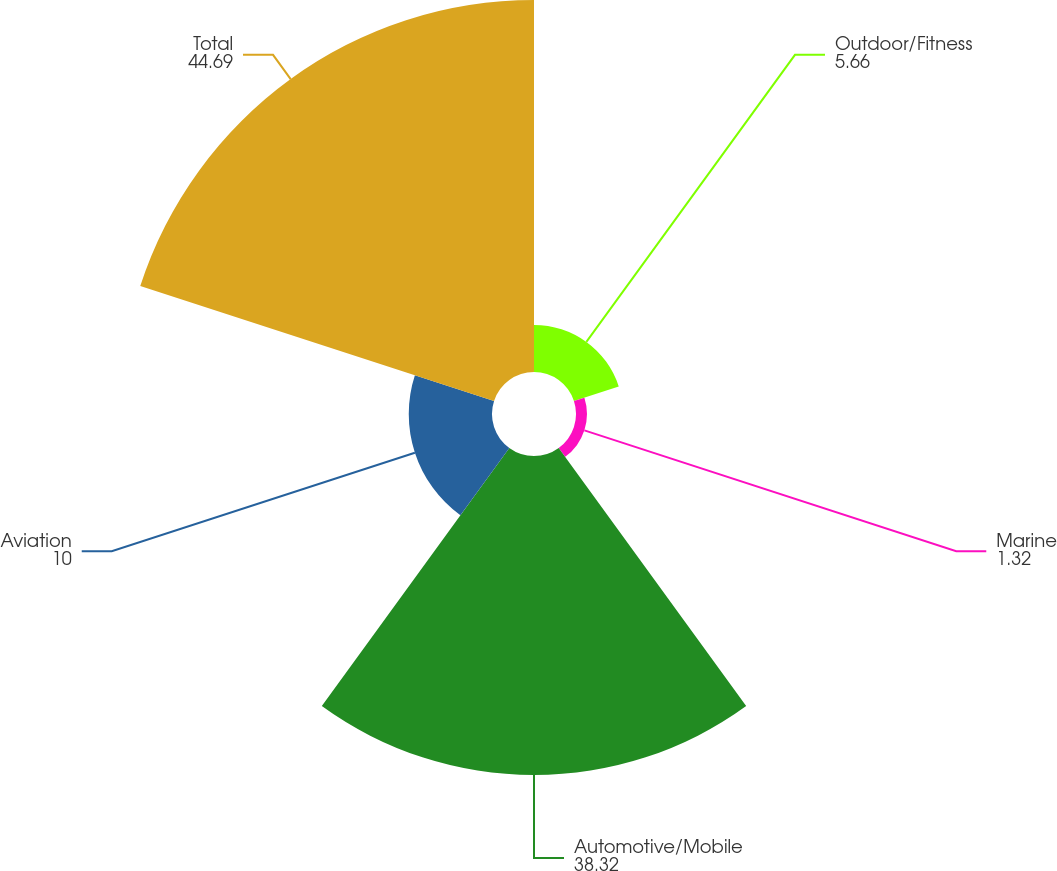Convert chart. <chart><loc_0><loc_0><loc_500><loc_500><pie_chart><fcel>Outdoor/Fitness<fcel>Marine<fcel>Automotive/Mobile<fcel>Aviation<fcel>Total<nl><fcel>5.66%<fcel>1.32%<fcel>38.32%<fcel>10.0%<fcel>44.69%<nl></chart> 